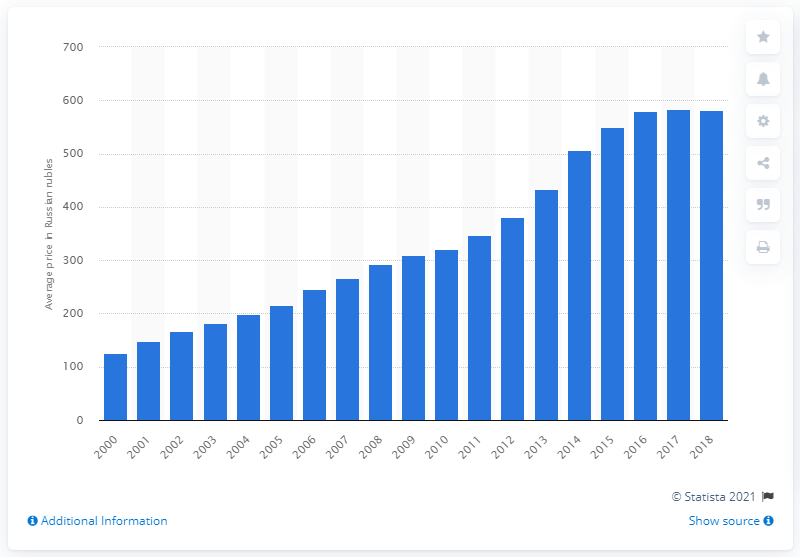Draw attention to some important aspects in this diagram. In 2016, alcohol prices became more stable. 